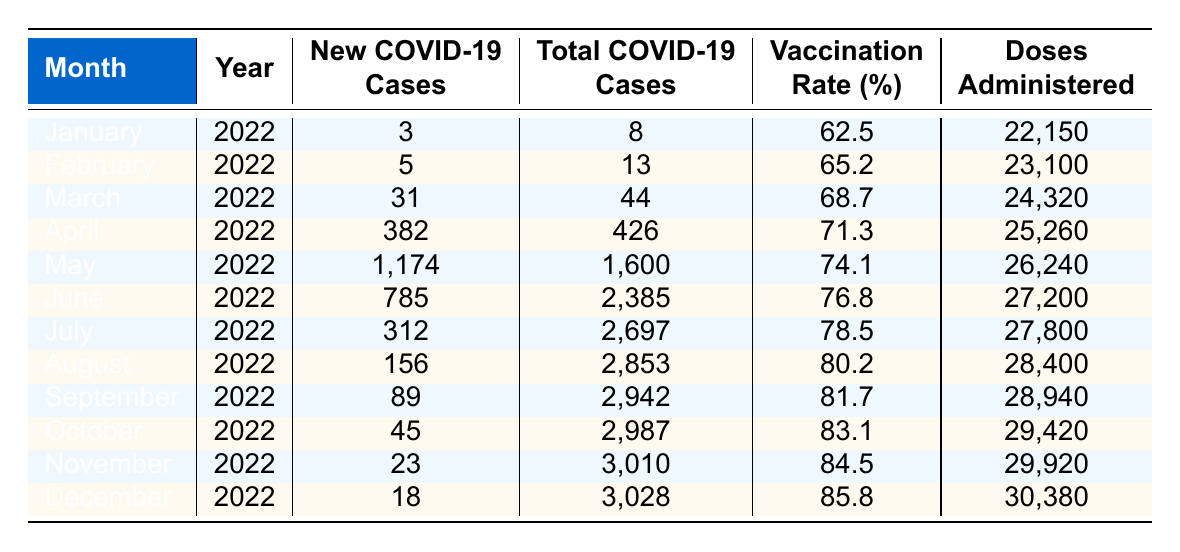What was the total number of new COVID-19 cases reported in American Samoa in December 2022? The table shows that December 2022 had 18 new COVID-19 cases, as listed in the corresponding row.
Answer: 18 What was the vaccination rate in American Samoa in June 2022? In June 2022, the vaccination rate listed in the table is 76.8%.
Answer: 76.8% What month had the highest number of new COVID-19 cases in 2022? By comparing the values in the "New COVID-19 Cases" column, May 2022 has the maximum number of new cases at 1,174.
Answer: May 2022 What is the average vaccination rate for American Samoa from January to December 2022? To calculate the average, add all the vaccination rates from January (62.5) to December (85.8) which equals  (62.5 + 65.2 + 68.7 + 71.3 + 74.1 + 76.8 + 78.5 + 80.2 + 81.7 + 83.1 + 84.5 + 85.8 =  72.19). Then divide by 12 months (72.19/12 = 76.10).
Answer: 76.10 How many doses were administered in total from January to April 2022? The table lists the doses administered for each month from January (22,150) to April (25,260). Adding these values gives (22,150 + 23,100 + 24,320 + 25,260 = 94,830).
Answer: 94,830 Was the total COVID-19 cases in March 2022 greater than that in January 2022? By checking the "Total COVID-19 Cases" column, March 2022 has 44 cases while January 2022 has 8 cases, confirming that March's total is greater.
Answer: Yes How many new COVID-19 cases were reported in the second half of the year (July to December 2022)? Adding the new cases for July (312), August (156), September (89), October (45), November (23), and December (18) comes to (312 + 156 + 89 + 45 + 23 + 18 = 643).
Answer: 643 Did the vaccination rate increase every month from January to December 2022? By examining the vaccination rates month by month, it is clear that the vaccination rate increased each month from January (62.5) to December (85.8) without any declines.
Answer: Yes What was the difference in new COVID-19 cases between May and June 2022? The table shows that May had 1,174 new cases and June had 785. The difference is calculated by subtracting June's cases from May's (1,174 - 785 = 389).
Answer: 389 Which month had a total of over 3,000 COVID-19 cases by the end of 2022? Referring to the "Total COVID-19 Cases" column, only December 2022 shows a total (3,028) that is over 3,000.
Answer: December 2022 What is the percentage increase in vaccination rate from January to December 2022? The vaccination rate in January was 62.5% and in December it was 85.8%. To find the increase, calculate (85.8 - 62.5 = 23.3). Then, compute the percentage increase by (23.3 / 62.5) * 100 = 37.28%.
Answer: 37.28% 